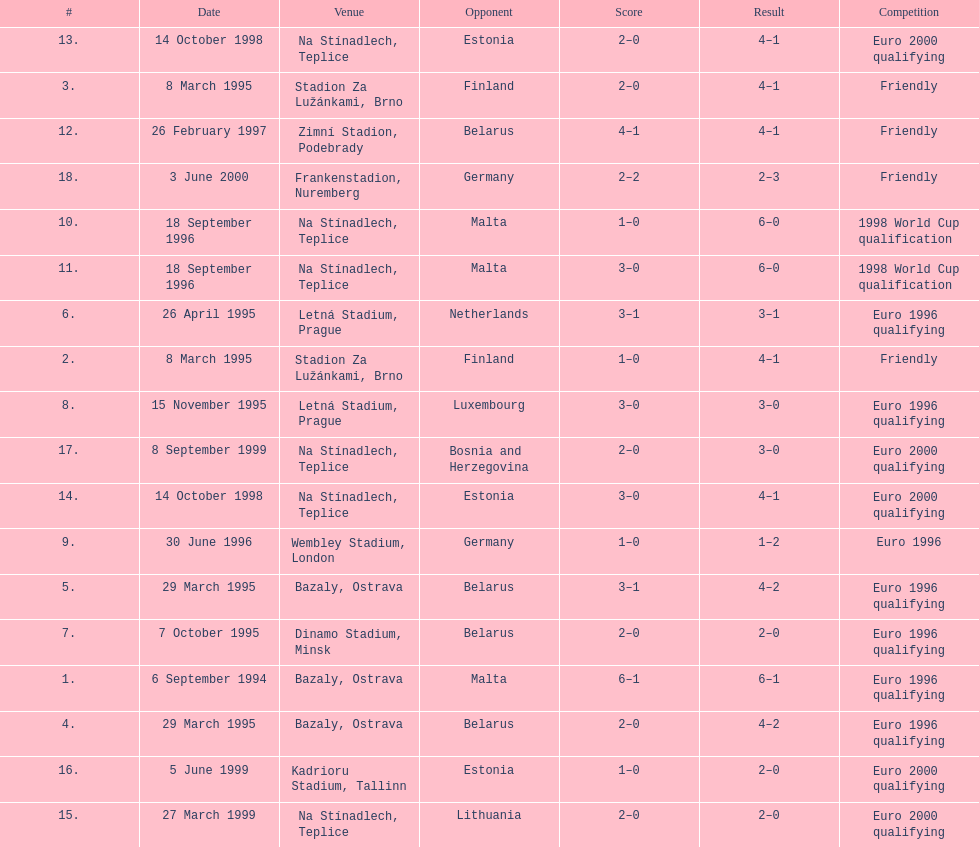What was the number of times czech republic played against germany? 2. 